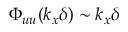Convert formula to latex. <formula><loc_0><loc_0><loc_500><loc_500>\Phi _ { u u } ( k _ { x } \delta ) \sim k _ { x } \delta</formula> 